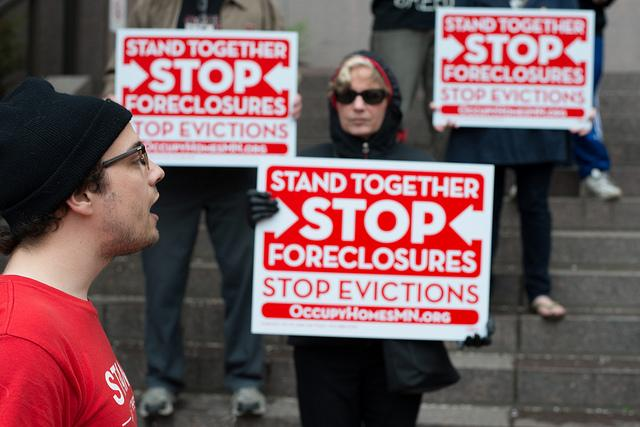What might the item on the woman's face be used to shield from? sun 